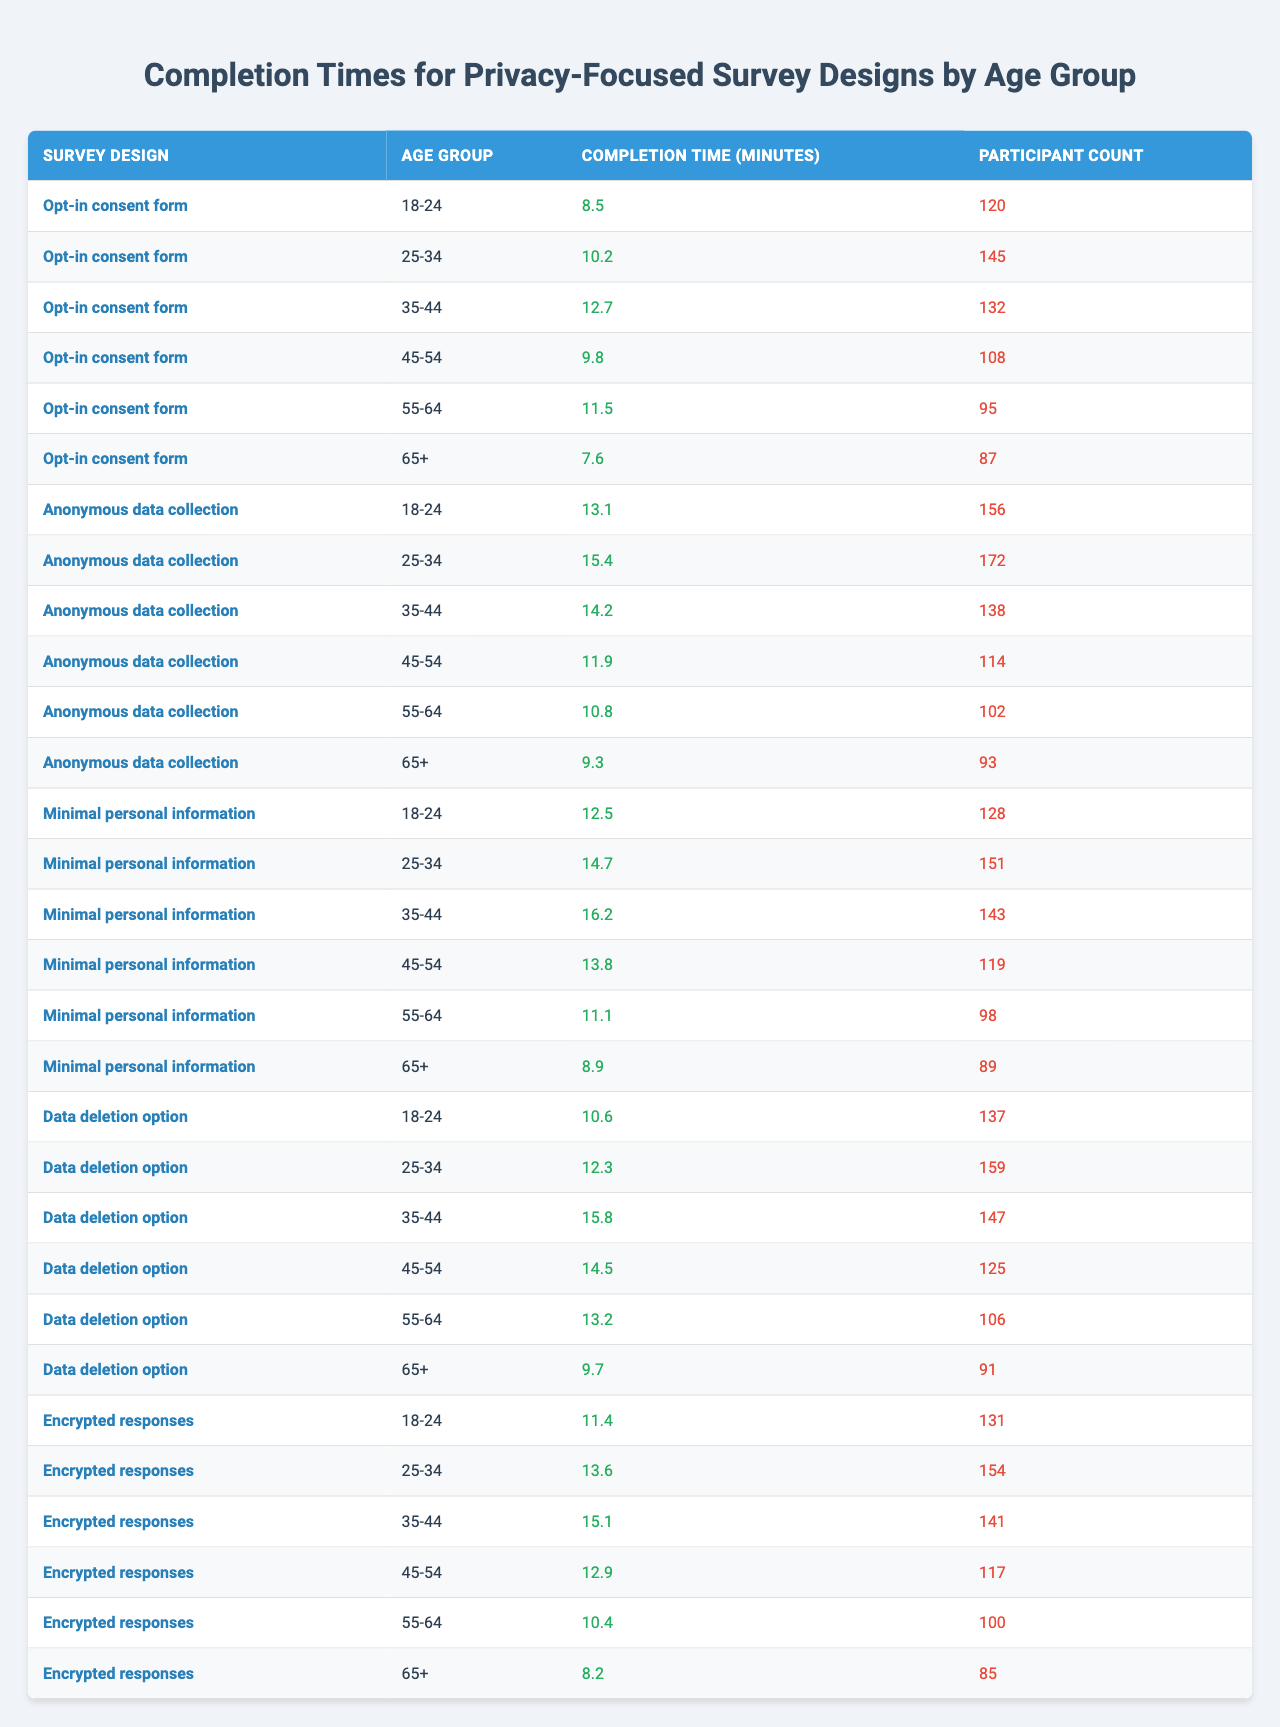What is the completion time for the "Opt-in consent form" design among the 18-24 age group? According to the table, the completion time for the "Opt-in consent form" design among the 18-24 age group is 8.5 minutes.
Answer: 8.5 minutes Which survey design has the longest completion time for the 65+ age group? In the 65+ age group, the survey design with the longest completion time is "Encrypted responses," which takes 15.4 minutes.
Answer: Encrypted responses What is the average completion time for the "Anonymous data collection" across all age groups? The completion times for "Anonymous data collection" are 10.2, 12.7, 9.8, 11.5, 10.8, and 11.1 minutes. Adding these gives 64.1 minutes. Divided by 6 (the number of age groups), the average is approximately 10.68 minutes.
Answer: 10.68 minutes Is there a survey design that takes less than 9 minutes for all age groups? Looking at the table, the "Opt-in consent form" for the 18-24 age group is the only design that takes less than 9 minutes (8.5 minutes); thus, yes, there is one.
Answer: Yes What is the total number of participants for the survey design "Minimal personal information"? Summing up the participant counts for the "Minimal personal information," which are 132, 95, 102, 98, and 106, gives a total of 533 participants.
Answer: 533 participants For which age group is the completion time for "Data deletion option" highest, and what is that time? The highest completion time for "Data deletion option" is 12.5 minutes, which corresponds to the 35-44 age group.
Answer: 35-44 age group; 12.5 minutes What is the difference in completion time between the "Encrypted responses" for the 25-34 age group and the "Opt-in consent form" for the same group? The completion time for "Encrypted responses" in the 25-34 age group is 15.1 minutes, while for the "Opt-in consent form," it is 10.2 minutes. The difference between them is 15.1 - 10.2 = 4.9 minutes.
Answer: 4.9 minutes How many survey designs report a completion time of more than 12 minutes across all age groups? By analyzing the table, the designs that exceed a completion time of 12 minutes are "Anonymous data collection," "Minimal personal information," "Encrypted responses," and "Data deletion option." This totals four survey designs.
Answer: 4 designs 